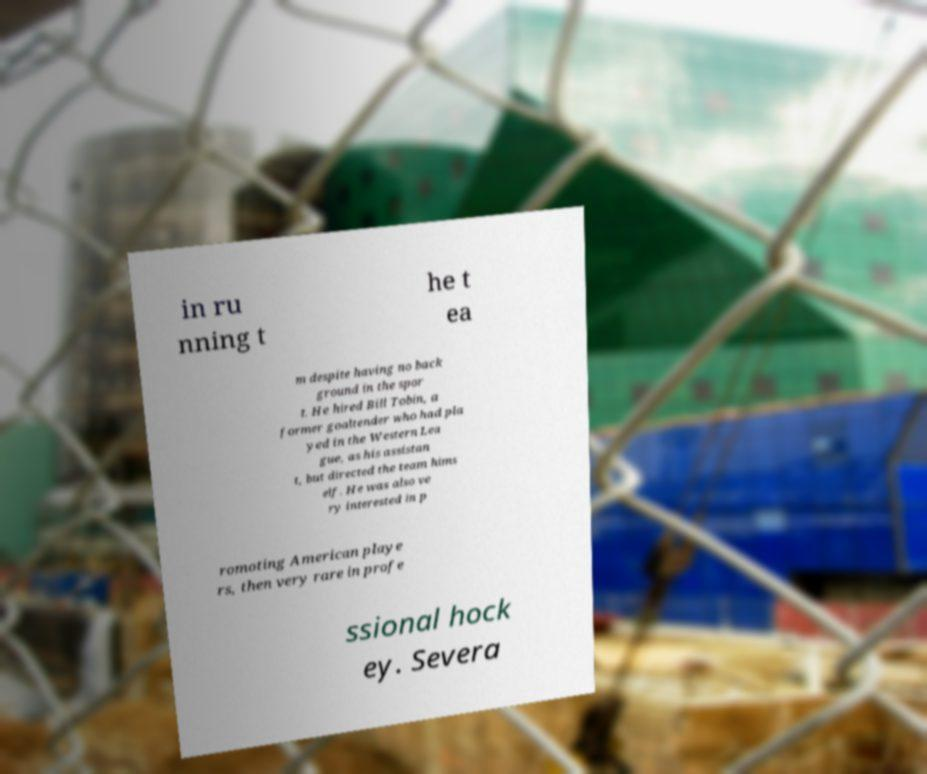What messages or text are displayed in this image? I need them in a readable, typed format. in ru nning t he t ea m despite having no back ground in the spor t. He hired Bill Tobin, a former goaltender who had pla yed in the Western Lea gue, as his assistan t, but directed the team hims elf. He was also ve ry interested in p romoting American playe rs, then very rare in profe ssional hock ey. Severa 